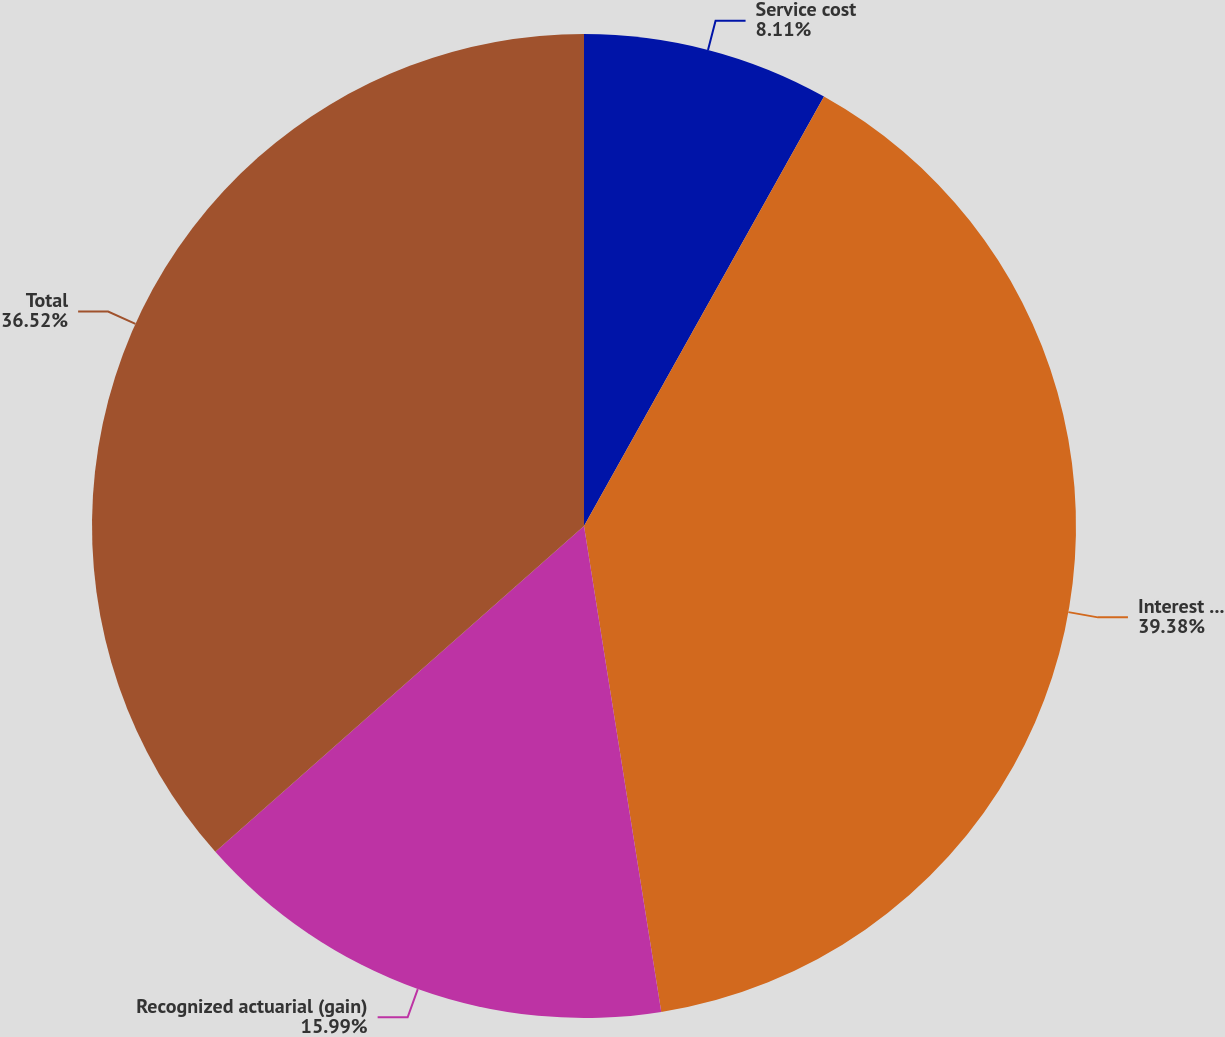<chart> <loc_0><loc_0><loc_500><loc_500><pie_chart><fcel>Service cost<fcel>Interest cost<fcel>Recognized actuarial (gain)<fcel>Total<nl><fcel>8.11%<fcel>39.38%<fcel>15.99%<fcel>36.52%<nl></chart> 